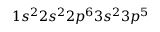<formula> <loc_0><loc_0><loc_500><loc_500>1 s ^ { 2 } 2 s ^ { 2 } 2 p ^ { 6 } 3 s ^ { 2 } 3 p ^ { 5 }</formula> 